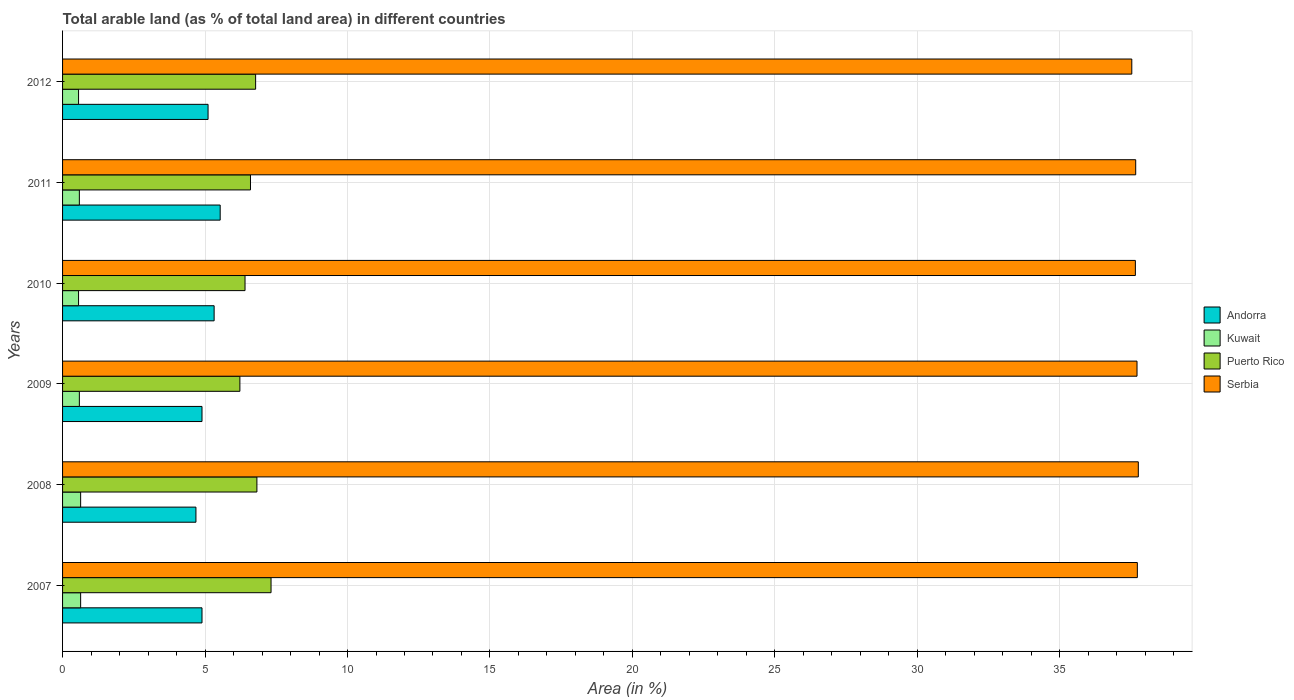How many different coloured bars are there?
Your answer should be compact. 4. Are the number of bars per tick equal to the number of legend labels?
Your answer should be compact. Yes. Are the number of bars on each tick of the Y-axis equal?
Give a very brief answer. Yes. How many bars are there on the 5th tick from the top?
Keep it short and to the point. 4. How many bars are there on the 5th tick from the bottom?
Provide a short and direct response. 4. In how many cases, is the number of bars for a given year not equal to the number of legend labels?
Offer a terse response. 0. What is the percentage of arable land in Puerto Rico in 2012?
Offer a very short reply. 6.78. Across all years, what is the maximum percentage of arable land in Andorra?
Your answer should be compact. 5.53. Across all years, what is the minimum percentage of arable land in Andorra?
Provide a short and direct response. 4.68. In which year was the percentage of arable land in Serbia maximum?
Offer a very short reply. 2008. In which year was the percentage of arable land in Kuwait minimum?
Offer a very short reply. 2010. What is the total percentage of arable land in Andorra in the graph?
Keep it short and to the point. 30.43. What is the difference between the percentage of arable land in Serbia in 2010 and that in 2011?
Your answer should be compact. -0.01. What is the difference between the percentage of arable land in Puerto Rico in 2009 and the percentage of arable land in Serbia in 2008?
Make the answer very short. -31.53. What is the average percentage of arable land in Andorra per year?
Ensure brevity in your answer.  5.07. In the year 2012, what is the difference between the percentage of arable land in Kuwait and percentage of arable land in Andorra?
Make the answer very short. -4.55. In how many years, is the percentage of arable land in Andorra greater than 7 %?
Provide a succinct answer. 0. What is the ratio of the percentage of arable land in Serbia in 2008 to that in 2010?
Your response must be concise. 1. What is the difference between the highest and the second highest percentage of arable land in Kuwait?
Offer a terse response. 0. What is the difference between the highest and the lowest percentage of arable land in Andorra?
Offer a terse response. 0.85. In how many years, is the percentage of arable land in Andorra greater than the average percentage of arable land in Andorra taken over all years?
Provide a short and direct response. 3. What does the 3rd bar from the top in 2009 represents?
Offer a very short reply. Kuwait. What does the 3rd bar from the bottom in 2008 represents?
Give a very brief answer. Puerto Rico. Is it the case that in every year, the sum of the percentage of arable land in Andorra and percentage of arable land in Kuwait is greater than the percentage of arable land in Puerto Rico?
Provide a short and direct response. No. How many bars are there?
Offer a terse response. 24. Does the graph contain any zero values?
Provide a short and direct response. No. Does the graph contain grids?
Provide a succinct answer. Yes. Where does the legend appear in the graph?
Provide a short and direct response. Center right. How many legend labels are there?
Your response must be concise. 4. What is the title of the graph?
Your response must be concise. Total arable land (as % of total land area) in different countries. Does "United Kingdom" appear as one of the legend labels in the graph?
Give a very brief answer. No. What is the label or title of the X-axis?
Offer a very short reply. Area (in %). What is the label or title of the Y-axis?
Provide a succinct answer. Years. What is the Area (in %) in Andorra in 2007?
Keep it short and to the point. 4.89. What is the Area (in %) of Kuwait in 2007?
Offer a terse response. 0.63. What is the Area (in %) of Puerto Rico in 2007?
Ensure brevity in your answer.  7.32. What is the Area (in %) in Serbia in 2007?
Make the answer very short. 37.72. What is the Area (in %) in Andorra in 2008?
Your answer should be compact. 4.68. What is the Area (in %) of Kuwait in 2008?
Make the answer very short. 0.63. What is the Area (in %) in Puerto Rico in 2008?
Ensure brevity in your answer.  6.82. What is the Area (in %) of Serbia in 2008?
Provide a short and direct response. 37.75. What is the Area (in %) of Andorra in 2009?
Ensure brevity in your answer.  4.89. What is the Area (in %) in Kuwait in 2009?
Keep it short and to the point. 0.59. What is the Area (in %) of Puerto Rico in 2009?
Provide a succinct answer. 6.22. What is the Area (in %) of Serbia in 2009?
Ensure brevity in your answer.  37.71. What is the Area (in %) of Andorra in 2010?
Make the answer very short. 5.32. What is the Area (in %) of Kuwait in 2010?
Provide a short and direct response. 0.56. What is the Area (in %) in Puerto Rico in 2010?
Your response must be concise. 6.4. What is the Area (in %) of Serbia in 2010?
Offer a very short reply. 37.65. What is the Area (in %) in Andorra in 2011?
Your answer should be very brief. 5.53. What is the Area (in %) of Kuwait in 2011?
Offer a terse response. 0.59. What is the Area (in %) in Puerto Rico in 2011?
Keep it short and to the point. 6.6. What is the Area (in %) in Serbia in 2011?
Give a very brief answer. 37.66. What is the Area (in %) in Andorra in 2012?
Your answer should be very brief. 5.11. What is the Area (in %) of Kuwait in 2012?
Provide a short and direct response. 0.56. What is the Area (in %) of Puerto Rico in 2012?
Your answer should be compact. 6.78. What is the Area (in %) in Serbia in 2012?
Your response must be concise. 37.53. Across all years, what is the maximum Area (in %) of Andorra?
Ensure brevity in your answer.  5.53. Across all years, what is the maximum Area (in %) of Kuwait?
Provide a succinct answer. 0.63. Across all years, what is the maximum Area (in %) in Puerto Rico?
Make the answer very short. 7.32. Across all years, what is the maximum Area (in %) of Serbia?
Provide a short and direct response. 37.75. Across all years, what is the minimum Area (in %) of Andorra?
Your answer should be very brief. 4.68. Across all years, what is the minimum Area (in %) in Kuwait?
Offer a terse response. 0.56. Across all years, what is the minimum Area (in %) in Puerto Rico?
Your answer should be compact. 6.22. Across all years, what is the minimum Area (in %) of Serbia?
Give a very brief answer. 37.53. What is the total Area (in %) in Andorra in the graph?
Provide a succinct answer. 30.43. What is the total Area (in %) in Kuwait in the graph?
Offer a terse response. 3.57. What is the total Area (in %) of Puerto Rico in the graph?
Ensure brevity in your answer.  40.14. What is the total Area (in %) of Serbia in the graph?
Provide a short and direct response. 226.02. What is the difference between the Area (in %) of Andorra in 2007 and that in 2008?
Make the answer very short. 0.21. What is the difference between the Area (in %) of Kuwait in 2007 and that in 2008?
Your answer should be compact. 0. What is the difference between the Area (in %) in Puerto Rico in 2007 and that in 2008?
Your answer should be very brief. 0.5. What is the difference between the Area (in %) of Serbia in 2007 and that in 2008?
Your response must be concise. -0.03. What is the difference between the Area (in %) of Kuwait in 2007 and that in 2009?
Your answer should be very brief. 0.04. What is the difference between the Area (in %) in Puerto Rico in 2007 and that in 2009?
Give a very brief answer. 1.09. What is the difference between the Area (in %) of Serbia in 2007 and that in 2009?
Give a very brief answer. 0.01. What is the difference between the Area (in %) of Andorra in 2007 and that in 2010?
Provide a short and direct response. -0.43. What is the difference between the Area (in %) in Kuwait in 2007 and that in 2010?
Offer a terse response. 0.07. What is the difference between the Area (in %) in Puerto Rico in 2007 and that in 2010?
Ensure brevity in your answer.  0.91. What is the difference between the Area (in %) of Serbia in 2007 and that in 2010?
Ensure brevity in your answer.  0.07. What is the difference between the Area (in %) in Andorra in 2007 and that in 2011?
Provide a succinct answer. -0.64. What is the difference between the Area (in %) of Kuwait in 2007 and that in 2011?
Your answer should be compact. 0.04. What is the difference between the Area (in %) of Puerto Rico in 2007 and that in 2011?
Make the answer very short. 0.72. What is the difference between the Area (in %) of Serbia in 2007 and that in 2011?
Provide a short and direct response. 0.06. What is the difference between the Area (in %) of Andorra in 2007 and that in 2012?
Your answer should be compact. -0.21. What is the difference between the Area (in %) in Kuwait in 2007 and that in 2012?
Your response must be concise. 0.07. What is the difference between the Area (in %) of Puerto Rico in 2007 and that in 2012?
Give a very brief answer. 0.54. What is the difference between the Area (in %) of Serbia in 2007 and that in 2012?
Your answer should be compact. 0.19. What is the difference between the Area (in %) of Andorra in 2008 and that in 2009?
Provide a succinct answer. -0.21. What is the difference between the Area (in %) of Kuwait in 2008 and that in 2009?
Provide a succinct answer. 0.04. What is the difference between the Area (in %) in Puerto Rico in 2008 and that in 2009?
Your answer should be very brief. 0.6. What is the difference between the Area (in %) in Serbia in 2008 and that in 2009?
Keep it short and to the point. 0.05. What is the difference between the Area (in %) of Andorra in 2008 and that in 2010?
Give a very brief answer. -0.64. What is the difference between the Area (in %) of Kuwait in 2008 and that in 2010?
Give a very brief answer. 0.07. What is the difference between the Area (in %) in Puerto Rico in 2008 and that in 2010?
Your answer should be very brief. 0.42. What is the difference between the Area (in %) in Serbia in 2008 and that in 2010?
Offer a very short reply. 0.1. What is the difference between the Area (in %) of Andorra in 2008 and that in 2011?
Offer a terse response. -0.85. What is the difference between the Area (in %) of Kuwait in 2008 and that in 2011?
Ensure brevity in your answer.  0.04. What is the difference between the Area (in %) in Puerto Rico in 2008 and that in 2011?
Ensure brevity in your answer.  0.23. What is the difference between the Area (in %) of Serbia in 2008 and that in 2011?
Keep it short and to the point. 0.09. What is the difference between the Area (in %) in Andorra in 2008 and that in 2012?
Offer a terse response. -0.43. What is the difference between the Area (in %) in Kuwait in 2008 and that in 2012?
Offer a terse response. 0.07. What is the difference between the Area (in %) of Puerto Rico in 2008 and that in 2012?
Offer a terse response. 0.05. What is the difference between the Area (in %) of Serbia in 2008 and that in 2012?
Offer a terse response. 0.23. What is the difference between the Area (in %) in Andorra in 2009 and that in 2010?
Your answer should be compact. -0.43. What is the difference between the Area (in %) of Kuwait in 2009 and that in 2010?
Your answer should be very brief. 0.03. What is the difference between the Area (in %) in Puerto Rico in 2009 and that in 2010?
Ensure brevity in your answer.  -0.18. What is the difference between the Area (in %) of Serbia in 2009 and that in 2010?
Your answer should be very brief. 0.06. What is the difference between the Area (in %) of Andorra in 2009 and that in 2011?
Give a very brief answer. -0.64. What is the difference between the Area (in %) in Puerto Rico in 2009 and that in 2011?
Your answer should be very brief. -0.37. What is the difference between the Area (in %) of Serbia in 2009 and that in 2011?
Your answer should be compact. 0.05. What is the difference between the Area (in %) of Andorra in 2009 and that in 2012?
Your response must be concise. -0.21. What is the difference between the Area (in %) of Kuwait in 2009 and that in 2012?
Offer a very short reply. 0.03. What is the difference between the Area (in %) in Puerto Rico in 2009 and that in 2012?
Your answer should be compact. -0.55. What is the difference between the Area (in %) of Serbia in 2009 and that in 2012?
Your response must be concise. 0.18. What is the difference between the Area (in %) of Andorra in 2010 and that in 2011?
Make the answer very short. -0.21. What is the difference between the Area (in %) in Kuwait in 2010 and that in 2011?
Offer a very short reply. -0.03. What is the difference between the Area (in %) of Puerto Rico in 2010 and that in 2011?
Ensure brevity in your answer.  -0.19. What is the difference between the Area (in %) of Serbia in 2010 and that in 2011?
Your answer should be compact. -0.01. What is the difference between the Area (in %) of Andorra in 2010 and that in 2012?
Offer a terse response. 0.21. What is the difference between the Area (in %) of Puerto Rico in 2010 and that in 2012?
Provide a short and direct response. -0.37. What is the difference between the Area (in %) of Serbia in 2010 and that in 2012?
Provide a short and direct response. 0.13. What is the difference between the Area (in %) of Andorra in 2011 and that in 2012?
Provide a succinct answer. 0.43. What is the difference between the Area (in %) of Kuwait in 2011 and that in 2012?
Keep it short and to the point. 0.03. What is the difference between the Area (in %) of Puerto Rico in 2011 and that in 2012?
Offer a very short reply. -0.18. What is the difference between the Area (in %) of Serbia in 2011 and that in 2012?
Ensure brevity in your answer.  0.14. What is the difference between the Area (in %) in Andorra in 2007 and the Area (in %) in Kuwait in 2008?
Your answer should be very brief. 4.26. What is the difference between the Area (in %) in Andorra in 2007 and the Area (in %) in Puerto Rico in 2008?
Your response must be concise. -1.93. What is the difference between the Area (in %) in Andorra in 2007 and the Area (in %) in Serbia in 2008?
Offer a very short reply. -32.86. What is the difference between the Area (in %) in Kuwait in 2007 and the Area (in %) in Puerto Rico in 2008?
Your response must be concise. -6.19. What is the difference between the Area (in %) in Kuwait in 2007 and the Area (in %) in Serbia in 2008?
Your response must be concise. -37.12. What is the difference between the Area (in %) in Puerto Rico in 2007 and the Area (in %) in Serbia in 2008?
Your response must be concise. -30.44. What is the difference between the Area (in %) of Andorra in 2007 and the Area (in %) of Kuwait in 2009?
Give a very brief answer. 4.3. What is the difference between the Area (in %) in Andorra in 2007 and the Area (in %) in Puerto Rico in 2009?
Keep it short and to the point. -1.33. What is the difference between the Area (in %) of Andorra in 2007 and the Area (in %) of Serbia in 2009?
Keep it short and to the point. -32.81. What is the difference between the Area (in %) of Kuwait in 2007 and the Area (in %) of Puerto Rico in 2009?
Your answer should be compact. -5.59. What is the difference between the Area (in %) in Kuwait in 2007 and the Area (in %) in Serbia in 2009?
Ensure brevity in your answer.  -37.07. What is the difference between the Area (in %) in Puerto Rico in 2007 and the Area (in %) in Serbia in 2009?
Offer a terse response. -30.39. What is the difference between the Area (in %) in Andorra in 2007 and the Area (in %) in Kuwait in 2010?
Provide a succinct answer. 4.33. What is the difference between the Area (in %) in Andorra in 2007 and the Area (in %) in Puerto Rico in 2010?
Provide a short and direct response. -1.51. What is the difference between the Area (in %) of Andorra in 2007 and the Area (in %) of Serbia in 2010?
Your response must be concise. -32.76. What is the difference between the Area (in %) in Kuwait in 2007 and the Area (in %) in Puerto Rico in 2010?
Your answer should be very brief. -5.77. What is the difference between the Area (in %) of Kuwait in 2007 and the Area (in %) of Serbia in 2010?
Make the answer very short. -37.02. What is the difference between the Area (in %) in Puerto Rico in 2007 and the Area (in %) in Serbia in 2010?
Offer a terse response. -30.33. What is the difference between the Area (in %) in Andorra in 2007 and the Area (in %) in Kuwait in 2011?
Offer a very short reply. 4.3. What is the difference between the Area (in %) of Andorra in 2007 and the Area (in %) of Puerto Rico in 2011?
Your answer should be compact. -1.7. What is the difference between the Area (in %) of Andorra in 2007 and the Area (in %) of Serbia in 2011?
Keep it short and to the point. -32.77. What is the difference between the Area (in %) of Kuwait in 2007 and the Area (in %) of Puerto Rico in 2011?
Your answer should be compact. -5.96. What is the difference between the Area (in %) of Kuwait in 2007 and the Area (in %) of Serbia in 2011?
Your answer should be compact. -37.03. What is the difference between the Area (in %) of Puerto Rico in 2007 and the Area (in %) of Serbia in 2011?
Make the answer very short. -30.35. What is the difference between the Area (in %) in Andorra in 2007 and the Area (in %) in Kuwait in 2012?
Your answer should be very brief. 4.33. What is the difference between the Area (in %) in Andorra in 2007 and the Area (in %) in Puerto Rico in 2012?
Ensure brevity in your answer.  -1.88. What is the difference between the Area (in %) in Andorra in 2007 and the Area (in %) in Serbia in 2012?
Your answer should be compact. -32.63. What is the difference between the Area (in %) in Kuwait in 2007 and the Area (in %) in Puerto Rico in 2012?
Make the answer very short. -6.14. What is the difference between the Area (in %) of Kuwait in 2007 and the Area (in %) of Serbia in 2012?
Provide a short and direct response. -36.89. What is the difference between the Area (in %) in Puerto Rico in 2007 and the Area (in %) in Serbia in 2012?
Your answer should be compact. -30.21. What is the difference between the Area (in %) in Andorra in 2008 and the Area (in %) in Kuwait in 2009?
Ensure brevity in your answer.  4.09. What is the difference between the Area (in %) in Andorra in 2008 and the Area (in %) in Puerto Rico in 2009?
Provide a short and direct response. -1.54. What is the difference between the Area (in %) in Andorra in 2008 and the Area (in %) in Serbia in 2009?
Ensure brevity in your answer.  -33.03. What is the difference between the Area (in %) in Kuwait in 2008 and the Area (in %) in Puerto Rico in 2009?
Provide a short and direct response. -5.59. What is the difference between the Area (in %) in Kuwait in 2008 and the Area (in %) in Serbia in 2009?
Your answer should be compact. -37.07. What is the difference between the Area (in %) of Puerto Rico in 2008 and the Area (in %) of Serbia in 2009?
Offer a terse response. -30.89. What is the difference between the Area (in %) of Andorra in 2008 and the Area (in %) of Kuwait in 2010?
Provide a short and direct response. 4.12. What is the difference between the Area (in %) of Andorra in 2008 and the Area (in %) of Puerto Rico in 2010?
Your answer should be compact. -1.72. What is the difference between the Area (in %) of Andorra in 2008 and the Area (in %) of Serbia in 2010?
Ensure brevity in your answer.  -32.97. What is the difference between the Area (in %) in Kuwait in 2008 and the Area (in %) in Puerto Rico in 2010?
Offer a terse response. -5.77. What is the difference between the Area (in %) of Kuwait in 2008 and the Area (in %) of Serbia in 2010?
Keep it short and to the point. -37.02. What is the difference between the Area (in %) of Puerto Rico in 2008 and the Area (in %) of Serbia in 2010?
Provide a succinct answer. -30.83. What is the difference between the Area (in %) in Andorra in 2008 and the Area (in %) in Kuwait in 2011?
Provide a short and direct response. 4.09. What is the difference between the Area (in %) of Andorra in 2008 and the Area (in %) of Puerto Rico in 2011?
Keep it short and to the point. -1.91. What is the difference between the Area (in %) in Andorra in 2008 and the Area (in %) in Serbia in 2011?
Your response must be concise. -32.98. What is the difference between the Area (in %) in Kuwait in 2008 and the Area (in %) in Puerto Rico in 2011?
Your response must be concise. -5.96. What is the difference between the Area (in %) of Kuwait in 2008 and the Area (in %) of Serbia in 2011?
Keep it short and to the point. -37.03. What is the difference between the Area (in %) of Puerto Rico in 2008 and the Area (in %) of Serbia in 2011?
Offer a very short reply. -30.84. What is the difference between the Area (in %) of Andorra in 2008 and the Area (in %) of Kuwait in 2012?
Provide a short and direct response. 4.12. What is the difference between the Area (in %) of Andorra in 2008 and the Area (in %) of Puerto Rico in 2012?
Keep it short and to the point. -2.09. What is the difference between the Area (in %) in Andorra in 2008 and the Area (in %) in Serbia in 2012?
Your response must be concise. -32.84. What is the difference between the Area (in %) of Kuwait in 2008 and the Area (in %) of Puerto Rico in 2012?
Ensure brevity in your answer.  -6.14. What is the difference between the Area (in %) of Kuwait in 2008 and the Area (in %) of Serbia in 2012?
Offer a terse response. -36.89. What is the difference between the Area (in %) in Puerto Rico in 2008 and the Area (in %) in Serbia in 2012?
Give a very brief answer. -30.7. What is the difference between the Area (in %) in Andorra in 2009 and the Area (in %) in Kuwait in 2010?
Offer a terse response. 4.33. What is the difference between the Area (in %) in Andorra in 2009 and the Area (in %) in Puerto Rico in 2010?
Make the answer very short. -1.51. What is the difference between the Area (in %) of Andorra in 2009 and the Area (in %) of Serbia in 2010?
Ensure brevity in your answer.  -32.76. What is the difference between the Area (in %) of Kuwait in 2009 and the Area (in %) of Puerto Rico in 2010?
Give a very brief answer. -5.81. What is the difference between the Area (in %) in Kuwait in 2009 and the Area (in %) in Serbia in 2010?
Ensure brevity in your answer.  -37.06. What is the difference between the Area (in %) in Puerto Rico in 2009 and the Area (in %) in Serbia in 2010?
Offer a very short reply. -31.43. What is the difference between the Area (in %) in Andorra in 2009 and the Area (in %) in Kuwait in 2011?
Your answer should be compact. 4.3. What is the difference between the Area (in %) of Andorra in 2009 and the Area (in %) of Puerto Rico in 2011?
Keep it short and to the point. -1.7. What is the difference between the Area (in %) in Andorra in 2009 and the Area (in %) in Serbia in 2011?
Ensure brevity in your answer.  -32.77. What is the difference between the Area (in %) in Kuwait in 2009 and the Area (in %) in Puerto Rico in 2011?
Offer a terse response. -6.01. What is the difference between the Area (in %) of Kuwait in 2009 and the Area (in %) of Serbia in 2011?
Give a very brief answer. -37.07. What is the difference between the Area (in %) in Puerto Rico in 2009 and the Area (in %) in Serbia in 2011?
Offer a very short reply. -31.44. What is the difference between the Area (in %) in Andorra in 2009 and the Area (in %) in Kuwait in 2012?
Keep it short and to the point. 4.33. What is the difference between the Area (in %) in Andorra in 2009 and the Area (in %) in Puerto Rico in 2012?
Ensure brevity in your answer.  -1.88. What is the difference between the Area (in %) in Andorra in 2009 and the Area (in %) in Serbia in 2012?
Offer a terse response. -32.63. What is the difference between the Area (in %) in Kuwait in 2009 and the Area (in %) in Puerto Rico in 2012?
Your answer should be compact. -6.19. What is the difference between the Area (in %) in Kuwait in 2009 and the Area (in %) in Serbia in 2012?
Offer a very short reply. -36.94. What is the difference between the Area (in %) in Puerto Rico in 2009 and the Area (in %) in Serbia in 2012?
Provide a succinct answer. -31.3. What is the difference between the Area (in %) of Andorra in 2010 and the Area (in %) of Kuwait in 2011?
Provide a short and direct response. 4.73. What is the difference between the Area (in %) of Andorra in 2010 and the Area (in %) of Puerto Rico in 2011?
Provide a succinct answer. -1.28. What is the difference between the Area (in %) of Andorra in 2010 and the Area (in %) of Serbia in 2011?
Provide a succinct answer. -32.34. What is the difference between the Area (in %) of Kuwait in 2010 and the Area (in %) of Puerto Rico in 2011?
Offer a terse response. -6.03. What is the difference between the Area (in %) of Kuwait in 2010 and the Area (in %) of Serbia in 2011?
Offer a terse response. -37.1. What is the difference between the Area (in %) in Puerto Rico in 2010 and the Area (in %) in Serbia in 2011?
Make the answer very short. -31.26. What is the difference between the Area (in %) of Andorra in 2010 and the Area (in %) of Kuwait in 2012?
Your answer should be very brief. 4.76. What is the difference between the Area (in %) of Andorra in 2010 and the Area (in %) of Puerto Rico in 2012?
Provide a succinct answer. -1.46. What is the difference between the Area (in %) in Andorra in 2010 and the Area (in %) in Serbia in 2012?
Provide a succinct answer. -32.21. What is the difference between the Area (in %) in Kuwait in 2010 and the Area (in %) in Puerto Rico in 2012?
Give a very brief answer. -6.21. What is the difference between the Area (in %) of Kuwait in 2010 and the Area (in %) of Serbia in 2012?
Provide a succinct answer. -36.96. What is the difference between the Area (in %) of Puerto Rico in 2010 and the Area (in %) of Serbia in 2012?
Make the answer very short. -31.12. What is the difference between the Area (in %) in Andorra in 2011 and the Area (in %) in Kuwait in 2012?
Ensure brevity in your answer.  4.97. What is the difference between the Area (in %) of Andorra in 2011 and the Area (in %) of Puerto Rico in 2012?
Offer a terse response. -1.24. What is the difference between the Area (in %) of Andorra in 2011 and the Area (in %) of Serbia in 2012?
Provide a short and direct response. -31.99. What is the difference between the Area (in %) in Kuwait in 2011 and the Area (in %) in Puerto Rico in 2012?
Keep it short and to the point. -6.19. What is the difference between the Area (in %) of Kuwait in 2011 and the Area (in %) of Serbia in 2012?
Offer a terse response. -36.94. What is the difference between the Area (in %) of Puerto Rico in 2011 and the Area (in %) of Serbia in 2012?
Offer a terse response. -30.93. What is the average Area (in %) of Andorra per year?
Keep it short and to the point. 5.07. What is the average Area (in %) in Kuwait per year?
Provide a succinct answer. 0.59. What is the average Area (in %) of Puerto Rico per year?
Keep it short and to the point. 6.69. What is the average Area (in %) in Serbia per year?
Offer a terse response. 37.67. In the year 2007, what is the difference between the Area (in %) of Andorra and Area (in %) of Kuwait?
Provide a succinct answer. 4.26. In the year 2007, what is the difference between the Area (in %) of Andorra and Area (in %) of Puerto Rico?
Your answer should be very brief. -2.42. In the year 2007, what is the difference between the Area (in %) of Andorra and Area (in %) of Serbia?
Make the answer very short. -32.83. In the year 2007, what is the difference between the Area (in %) of Kuwait and Area (in %) of Puerto Rico?
Your response must be concise. -6.68. In the year 2007, what is the difference between the Area (in %) of Kuwait and Area (in %) of Serbia?
Your response must be concise. -37.09. In the year 2007, what is the difference between the Area (in %) in Puerto Rico and Area (in %) in Serbia?
Provide a short and direct response. -30.4. In the year 2008, what is the difference between the Area (in %) of Andorra and Area (in %) of Kuwait?
Provide a succinct answer. 4.05. In the year 2008, what is the difference between the Area (in %) of Andorra and Area (in %) of Puerto Rico?
Make the answer very short. -2.14. In the year 2008, what is the difference between the Area (in %) of Andorra and Area (in %) of Serbia?
Your answer should be compact. -33.07. In the year 2008, what is the difference between the Area (in %) of Kuwait and Area (in %) of Puerto Rico?
Make the answer very short. -6.19. In the year 2008, what is the difference between the Area (in %) in Kuwait and Area (in %) in Serbia?
Give a very brief answer. -37.12. In the year 2008, what is the difference between the Area (in %) in Puerto Rico and Area (in %) in Serbia?
Offer a very short reply. -30.93. In the year 2009, what is the difference between the Area (in %) in Andorra and Area (in %) in Kuwait?
Keep it short and to the point. 4.3. In the year 2009, what is the difference between the Area (in %) in Andorra and Area (in %) in Puerto Rico?
Your answer should be compact. -1.33. In the year 2009, what is the difference between the Area (in %) of Andorra and Area (in %) of Serbia?
Your response must be concise. -32.81. In the year 2009, what is the difference between the Area (in %) in Kuwait and Area (in %) in Puerto Rico?
Ensure brevity in your answer.  -5.63. In the year 2009, what is the difference between the Area (in %) of Kuwait and Area (in %) of Serbia?
Offer a very short reply. -37.12. In the year 2009, what is the difference between the Area (in %) of Puerto Rico and Area (in %) of Serbia?
Your response must be concise. -31.49. In the year 2010, what is the difference between the Area (in %) of Andorra and Area (in %) of Kuwait?
Make the answer very short. 4.76. In the year 2010, what is the difference between the Area (in %) of Andorra and Area (in %) of Puerto Rico?
Your answer should be compact. -1.08. In the year 2010, what is the difference between the Area (in %) in Andorra and Area (in %) in Serbia?
Your answer should be very brief. -32.33. In the year 2010, what is the difference between the Area (in %) in Kuwait and Area (in %) in Puerto Rico?
Ensure brevity in your answer.  -5.84. In the year 2010, what is the difference between the Area (in %) in Kuwait and Area (in %) in Serbia?
Give a very brief answer. -37.09. In the year 2010, what is the difference between the Area (in %) of Puerto Rico and Area (in %) of Serbia?
Give a very brief answer. -31.25. In the year 2011, what is the difference between the Area (in %) of Andorra and Area (in %) of Kuwait?
Give a very brief answer. 4.94. In the year 2011, what is the difference between the Area (in %) of Andorra and Area (in %) of Puerto Rico?
Offer a terse response. -1.06. In the year 2011, what is the difference between the Area (in %) in Andorra and Area (in %) in Serbia?
Keep it short and to the point. -32.13. In the year 2011, what is the difference between the Area (in %) in Kuwait and Area (in %) in Puerto Rico?
Provide a succinct answer. -6.01. In the year 2011, what is the difference between the Area (in %) in Kuwait and Area (in %) in Serbia?
Your response must be concise. -37.07. In the year 2011, what is the difference between the Area (in %) in Puerto Rico and Area (in %) in Serbia?
Your answer should be very brief. -31.07. In the year 2012, what is the difference between the Area (in %) of Andorra and Area (in %) of Kuwait?
Keep it short and to the point. 4.55. In the year 2012, what is the difference between the Area (in %) in Andorra and Area (in %) in Puerto Rico?
Offer a terse response. -1.67. In the year 2012, what is the difference between the Area (in %) in Andorra and Area (in %) in Serbia?
Offer a very short reply. -32.42. In the year 2012, what is the difference between the Area (in %) of Kuwait and Area (in %) of Puerto Rico?
Your answer should be very brief. -6.21. In the year 2012, what is the difference between the Area (in %) in Kuwait and Area (in %) in Serbia?
Your answer should be very brief. -36.96. In the year 2012, what is the difference between the Area (in %) in Puerto Rico and Area (in %) in Serbia?
Offer a terse response. -30.75. What is the ratio of the Area (in %) in Andorra in 2007 to that in 2008?
Keep it short and to the point. 1.05. What is the ratio of the Area (in %) in Kuwait in 2007 to that in 2008?
Keep it short and to the point. 1. What is the ratio of the Area (in %) of Puerto Rico in 2007 to that in 2008?
Keep it short and to the point. 1.07. What is the ratio of the Area (in %) of Serbia in 2007 to that in 2008?
Your answer should be compact. 1. What is the ratio of the Area (in %) in Andorra in 2007 to that in 2009?
Offer a very short reply. 1. What is the ratio of the Area (in %) in Kuwait in 2007 to that in 2009?
Offer a terse response. 1.08. What is the ratio of the Area (in %) in Puerto Rico in 2007 to that in 2009?
Give a very brief answer. 1.18. What is the ratio of the Area (in %) in Kuwait in 2007 to that in 2010?
Offer a terse response. 1.13. What is the ratio of the Area (in %) of Puerto Rico in 2007 to that in 2010?
Provide a succinct answer. 1.14. What is the ratio of the Area (in %) of Andorra in 2007 to that in 2011?
Your response must be concise. 0.88. What is the ratio of the Area (in %) in Kuwait in 2007 to that in 2011?
Provide a short and direct response. 1.08. What is the ratio of the Area (in %) in Puerto Rico in 2007 to that in 2011?
Provide a short and direct response. 1.11. What is the ratio of the Area (in %) in Serbia in 2007 to that in 2011?
Your response must be concise. 1. What is the ratio of the Area (in %) in Andorra in 2007 to that in 2012?
Keep it short and to the point. 0.96. What is the ratio of the Area (in %) in Kuwait in 2007 to that in 2012?
Give a very brief answer. 1.13. What is the ratio of the Area (in %) in Puerto Rico in 2007 to that in 2012?
Ensure brevity in your answer.  1.08. What is the ratio of the Area (in %) of Andorra in 2008 to that in 2009?
Your answer should be very brief. 0.96. What is the ratio of the Area (in %) of Kuwait in 2008 to that in 2009?
Offer a very short reply. 1.08. What is the ratio of the Area (in %) in Puerto Rico in 2008 to that in 2009?
Provide a short and direct response. 1.1. What is the ratio of the Area (in %) in Serbia in 2008 to that in 2009?
Provide a short and direct response. 1. What is the ratio of the Area (in %) of Andorra in 2008 to that in 2010?
Offer a very short reply. 0.88. What is the ratio of the Area (in %) in Kuwait in 2008 to that in 2010?
Your answer should be compact. 1.13. What is the ratio of the Area (in %) in Puerto Rico in 2008 to that in 2010?
Your response must be concise. 1.07. What is the ratio of the Area (in %) in Serbia in 2008 to that in 2010?
Your answer should be very brief. 1. What is the ratio of the Area (in %) of Andorra in 2008 to that in 2011?
Provide a succinct answer. 0.85. What is the ratio of the Area (in %) of Kuwait in 2008 to that in 2011?
Give a very brief answer. 1.08. What is the ratio of the Area (in %) of Puerto Rico in 2008 to that in 2011?
Make the answer very short. 1.03. What is the ratio of the Area (in %) in Serbia in 2008 to that in 2011?
Provide a short and direct response. 1. What is the ratio of the Area (in %) of Andorra in 2008 to that in 2012?
Keep it short and to the point. 0.92. What is the ratio of the Area (in %) of Kuwait in 2008 to that in 2012?
Your answer should be compact. 1.13. What is the ratio of the Area (in %) in Kuwait in 2009 to that in 2010?
Offer a terse response. 1.05. What is the ratio of the Area (in %) of Puerto Rico in 2009 to that in 2010?
Provide a succinct answer. 0.97. What is the ratio of the Area (in %) in Serbia in 2009 to that in 2010?
Your answer should be compact. 1. What is the ratio of the Area (in %) in Andorra in 2009 to that in 2011?
Your answer should be very brief. 0.88. What is the ratio of the Area (in %) in Puerto Rico in 2009 to that in 2011?
Your answer should be very brief. 0.94. What is the ratio of the Area (in %) of Serbia in 2009 to that in 2011?
Offer a very short reply. 1. What is the ratio of the Area (in %) of Kuwait in 2009 to that in 2012?
Provide a succinct answer. 1.05. What is the ratio of the Area (in %) of Puerto Rico in 2009 to that in 2012?
Ensure brevity in your answer.  0.92. What is the ratio of the Area (in %) in Serbia in 2009 to that in 2012?
Give a very brief answer. 1. What is the ratio of the Area (in %) of Andorra in 2010 to that in 2011?
Provide a succinct answer. 0.96. What is the ratio of the Area (in %) of Puerto Rico in 2010 to that in 2011?
Ensure brevity in your answer.  0.97. What is the ratio of the Area (in %) in Serbia in 2010 to that in 2011?
Provide a short and direct response. 1. What is the ratio of the Area (in %) in Andorra in 2010 to that in 2012?
Give a very brief answer. 1.04. What is the ratio of the Area (in %) in Kuwait in 2010 to that in 2012?
Your answer should be very brief. 1. What is the ratio of the Area (in %) of Puerto Rico in 2010 to that in 2012?
Make the answer very short. 0.95. What is the ratio of the Area (in %) in Andorra in 2011 to that in 2012?
Keep it short and to the point. 1.08. What is the ratio of the Area (in %) in Puerto Rico in 2011 to that in 2012?
Your answer should be very brief. 0.97. What is the difference between the highest and the second highest Area (in %) of Andorra?
Make the answer very short. 0.21. What is the difference between the highest and the second highest Area (in %) in Kuwait?
Offer a very short reply. 0. What is the difference between the highest and the second highest Area (in %) of Puerto Rico?
Give a very brief answer. 0.5. What is the difference between the highest and the second highest Area (in %) of Serbia?
Your response must be concise. 0.03. What is the difference between the highest and the lowest Area (in %) of Andorra?
Your response must be concise. 0.85. What is the difference between the highest and the lowest Area (in %) in Kuwait?
Provide a short and direct response. 0.07. What is the difference between the highest and the lowest Area (in %) in Puerto Rico?
Offer a very short reply. 1.09. What is the difference between the highest and the lowest Area (in %) of Serbia?
Your answer should be compact. 0.23. 